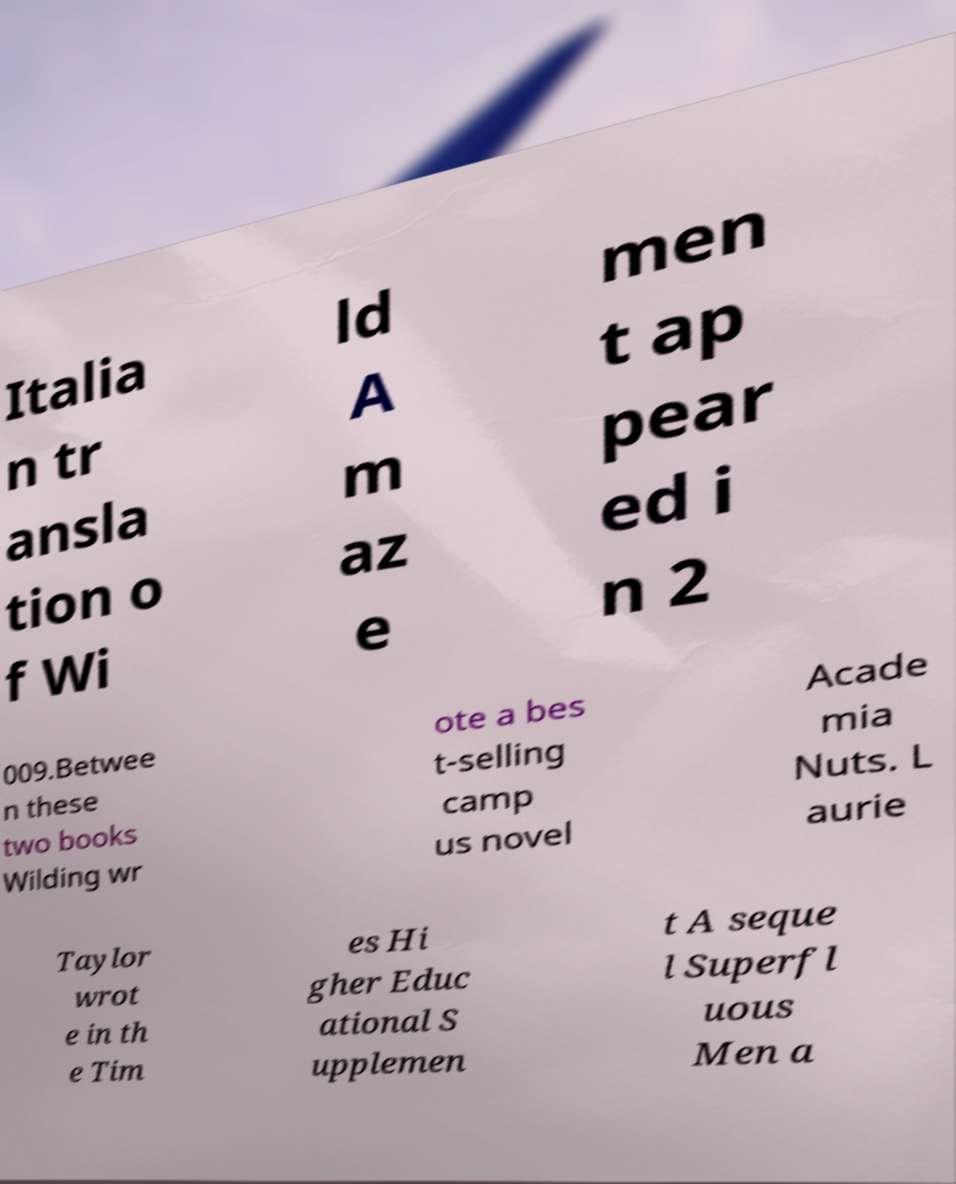What messages or text are displayed in this image? I need them in a readable, typed format. Italia n tr ansla tion o f Wi ld A m az e men t ap pear ed i n 2 009.Betwee n these two books Wilding wr ote a bes t-selling camp us novel Acade mia Nuts. L aurie Taylor wrot e in th e Tim es Hi gher Educ ational S upplemen t A seque l Superfl uous Men a 